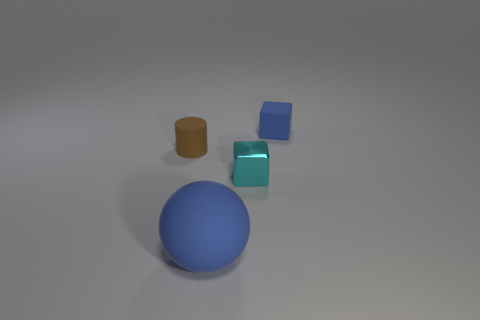Is there any other thing that is made of the same material as the cyan object?
Your response must be concise. No. There is a thing that is to the right of the blue sphere and in front of the tiny blue object; what material is it?
Offer a very short reply. Metal. Is the shape of the small cyan shiny object the same as the blue rubber object in front of the blue block?
Provide a succinct answer. No. There is a blue thing behind the tiny cyan shiny thing; is it the same shape as the big object?
Make the answer very short. No. There is another thing that is the same shape as the tiny blue object; what is it made of?
Your answer should be very brief. Metal. How many spheres are either small green rubber things or tiny cyan shiny objects?
Provide a succinct answer. 0. What number of tiny blue things are the same shape as the tiny cyan metal thing?
Make the answer very short. 1. Is the number of rubber spheres that are to the left of the cyan thing greater than the number of blue blocks to the left of the blue matte block?
Keep it short and to the point. Yes. Do the rubber object that is to the right of the blue ball and the sphere have the same color?
Provide a succinct answer. Yes. What size is the cylinder?
Offer a terse response. Small. 